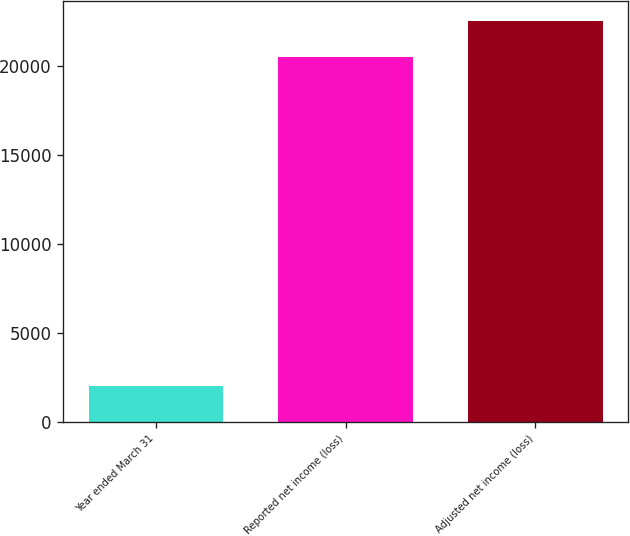Convert chart to OTSL. <chart><loc_0><loc_0><loc_500><loc_500><bar_chart><fcel>Year ended March 31<fcel>Reported net income (loss)<fcel>Adjusted net income (loss)<nl><fcel>2001<fcel>20507<fcel>22507.8<nl></chart> 